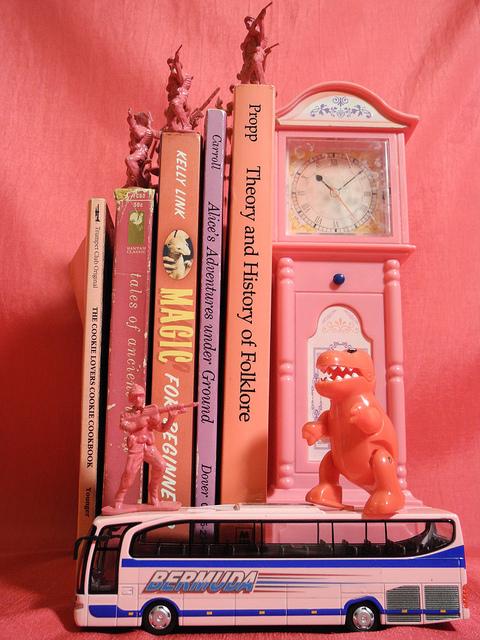What is the title of the book closest to the toy clock?
Keep it brief. Theory and history of folklore. What species of dinosaur is on top of the vehicle in the scene?
Short answer required. T-rex. What is written on the bus?
Quick response, please. Bermuda. 